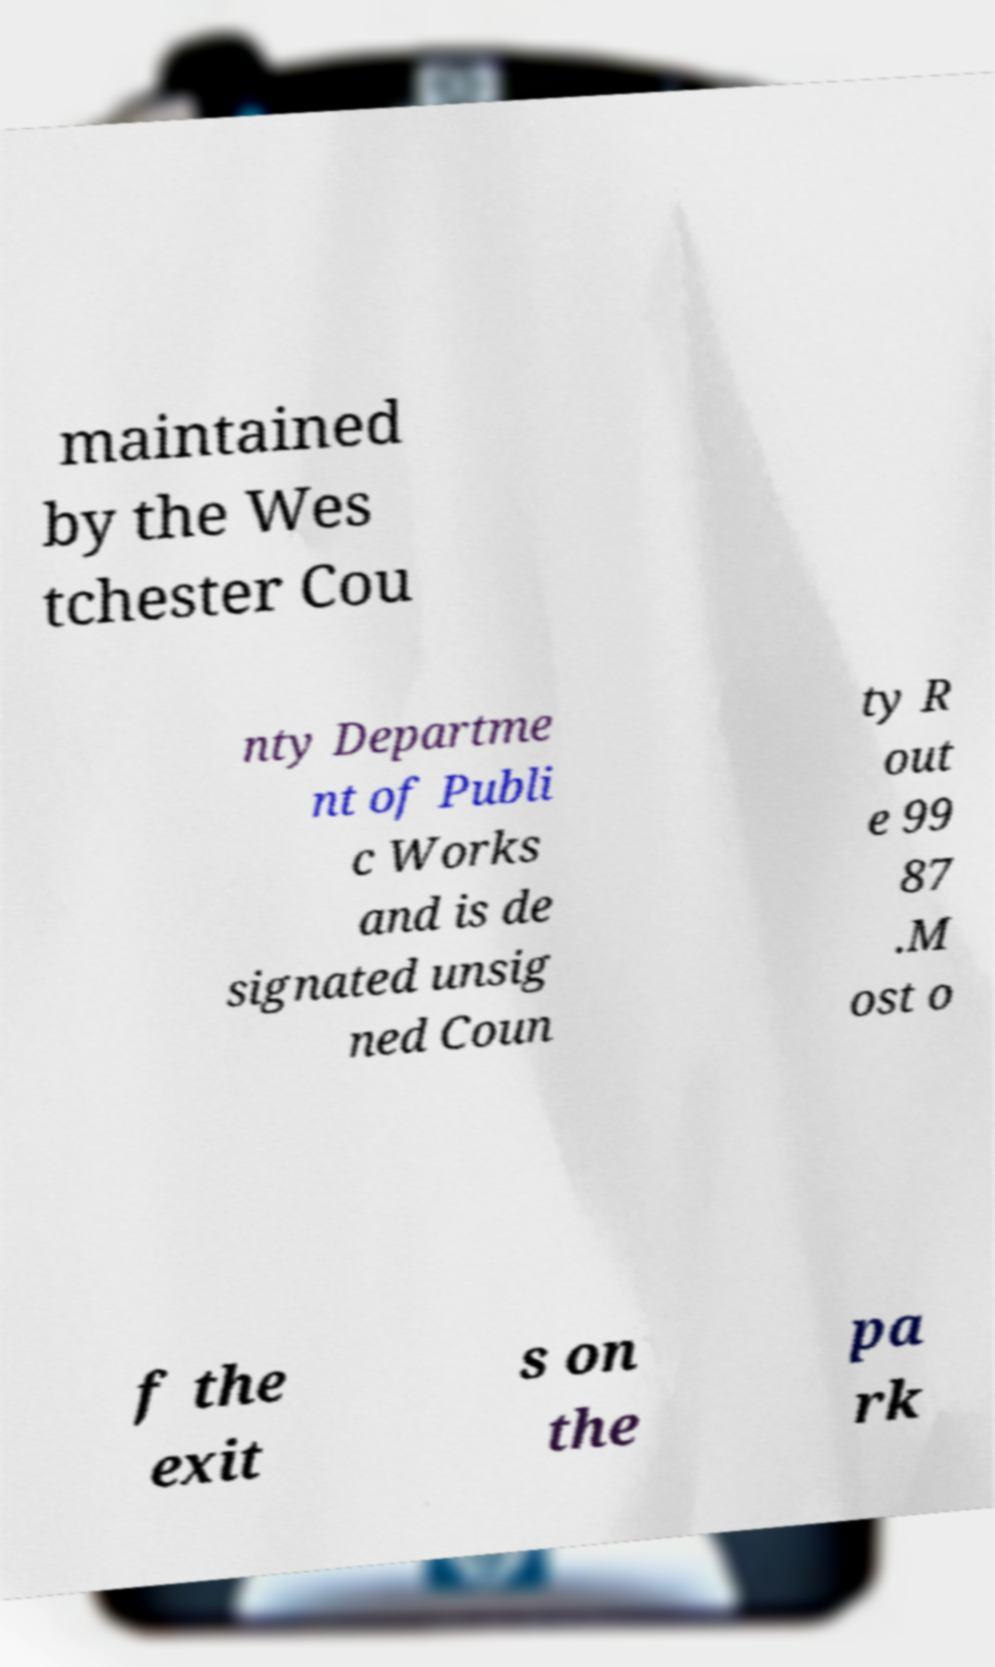There's text embedded in this image that I need extracted. Can you transcribe it verbatim? maintained by the Wes tchester Cou nty Departme nt of Publi c Works and is de signated unsig ned Coun ty R out e 99 87 .M ost o f the exit s on the pa rk 